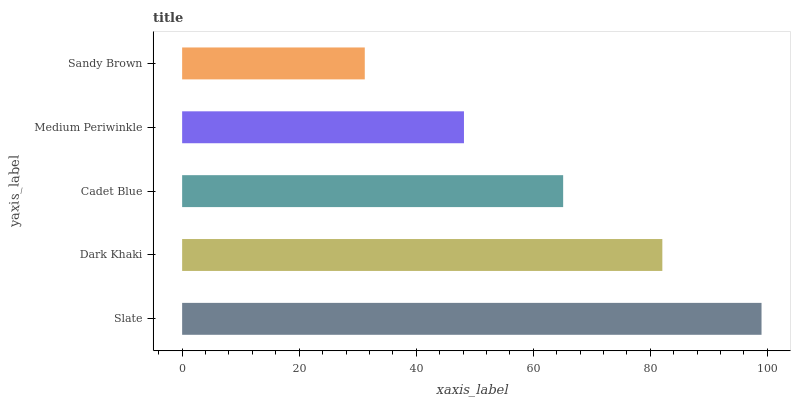Is Sandy Brown the minimum?
Answer yes or no. Yes. Is Slate the maximum?
Answer yes or no. Yes. Is Dark Khaki the minimum?
Answer yes or no. No. Is Dark Khaki the maximum?
Answer yes or no. No. Is Slate greater than Dark Khaki?
Answer yes or no. Yes. Is Dark Khaki less than Slate?
Answer yes or no. Yes. Is Dark Khaki greater than Slate?
Answer yes or no. No. Is Slate less than Dark Khaki?
Answer yes or no. No. Is Cadet Blue the high median?
Answer yes or no. Yes. Is Cadet Blue the low median?
Answer yes or no. Yes. Is Medium Periwinkle the high median?
Answer yes or no. No. Is Slate the low median?
Answer yes or no. No. 